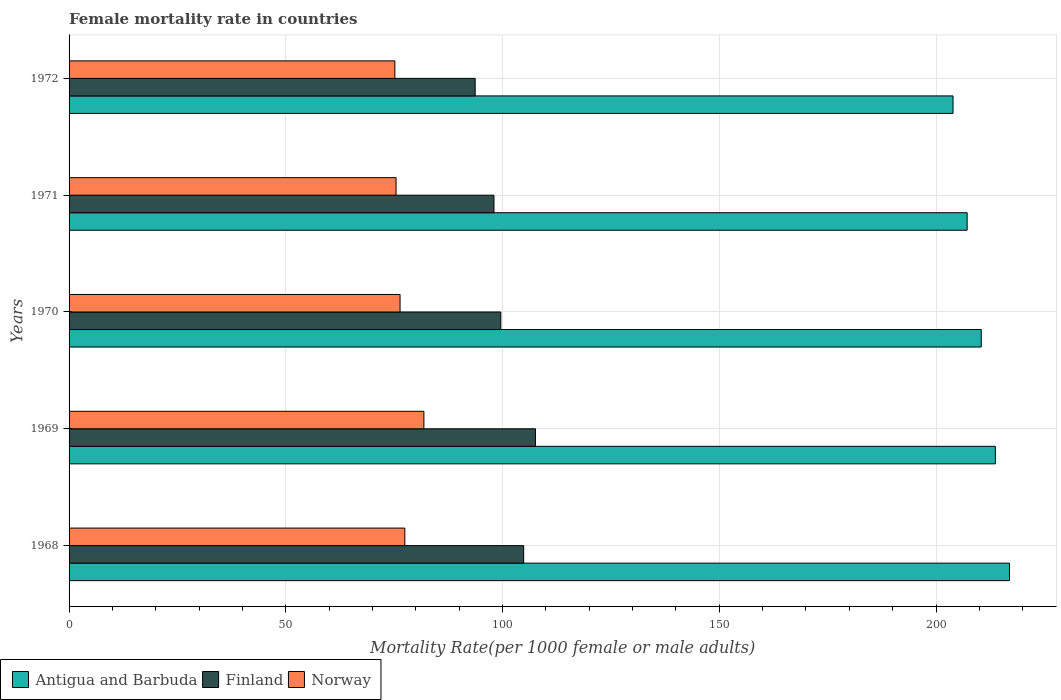How many different coloured bars are there?
Your answer should be compact. 3. How many groups of bars are there?
Provide a succinct answer. 5. Are the number of bars per tick equal to the number of legend labels?
Give a very brief answer. Yes. How many bars are there on the 3rd tick from the bottom?
Make the answer very short. 3. What is the label of the 4th group of bars from the top?
Your response must be concise. 1969. In how many cases, is the number of bars for a given year not equal to the number of legend labels?
Your answer should be very brief. 0. What is the female mortality rate in Norway in 1970?
Make the answer very short. 76.36. Across all years, what is the maximum female mortality rate in Antigua and Barbuda?
Ensure brevity in your answer.  216.95. Across all years, what is the minimum female mortality rate in Antigua and Barbuda?
Offer a very short reply. 203.93. In which year was the female mortality rate in Antigua and Barbuda maximum?
Give a very brief answer. 1968. What is the total female mortality rate in Antigua and Barbuda in the graph?
Your response must be concise. 1052.2. What is the difference between the female mortality rate in Norway in 1968 and that in 1972?
Make the answer very short. 2.3. What is the difference between the female mortality rate in Antigua and Barbuda in 1970 and the female mortality rate in Norway in 1972?
Your response must be concise. 135.28. What is the average female mortality rate in Finland per year?
Make the answer very short. 100.76. In the year 1968, what is the difference between the female mortality rate in Norway and female mortality rate in Finland?
Your response must be concise. -27.41. In how many years, is the female mortality rate in Antigua and Barbuda greater than 10 ?
Make the answer very short. 5. What is the ratio of the female mortality rate in Finland in 1969 to that in 1971?
Your answer should be very brief. 1.1. Is the difference between the female mortality rate in Norway in 1968 and 1970 greater than the difference between the female mortality rate in Finland in 1968 and 1970?
Keep it short and to the point. No. What is the difference between the highest and the second highest female mortality rate in Antigua and Barbuda?
Ensure brevity in your answer.  3.25. What is the difference between the highest and the lowest female mortality rate in Finland?
Give a very brief answer. 13.9. In how many years, is the female mortality rate in Antigua and Barbuda greater than the average female mortality rate in Antigua and Barbuda taken over all years?
Provide a short and direct response. 3. Are all the bars in the graph horizontal?
Offer a terse response. Yes. How many years are there in the graph?
Provide a succinct answer. 5. What is the difference between two consecutive major ticks on the X-axis?
Your answer should be compact. 50. Are the values on the major ticks of X-axis written in scientific E-notation?
Your response must be concise. No. Does the graph contain any zero values?
Offer a very short reply. No. How many legend labels are there?
Your answer should be compact. 3. What is the title of the graph?
Keep it short and to the point. Female mortality rate in countries. What is the label or title of the X-axis?
Make the answer very short. Mortality Rate(per 1000 female or male adults). What is the label or title of the Y-axis?
Keep it short and to the point. Years. What is the Mortality Rate(per 1000 female or male adults) in Antigua and Barbuda in 1968?
Provide a short and direct response. 216.95. What is the Mortality Rate(per 1000 female or male adults) of Finland in 1968?
Your answer should be very brief. 104.88. What is the Mortality Rate(per 1000 female or male adults) in Norway in 1968?
Make the answer very short. 77.46. What is the Mortality Rate(per 1000 female or male adults) in Antigua and Barbuda in 1969?
Your response must be concise. 213.7. What is the Mortality Rate(per 1000 female or male adults) in Finland in 1969?
Your response must be concise. 107.59. What is the Mortality Rate(per 1000 female or male adults) of Norway in 1969?
Provide a succinct answer. 81.86. What is the Mortality Rate(per 1000 female or male adults) of Antigua and Barbuda in 1970?
Give a very brief answer. 210.44. What is the Mortality Rate(per 1000 female or male adults) in Finland in 1970?
Provide a short and direct response. 99.6. What is the Mortality Rate(per 1000 female or male adults) of Norway in 1970?
Offer a very short reply. 76.36. What is the Mortality Rate(per 1000 female or male adults) in Antigua and Barbuda in 1971?
Offer a terse response. 207.19. What is the Mortality Rate(per 1000 female or male adults) in Finland in 1971?
Make the answer very short. 98.03. What is the Mortality Rate(per 1000 female or male adults) of Norway in 1971?
Give a very brief answer. 75.44. What is the Mortality Rate(per 1000 female or male adults) of Antigua and Barbuda in 1972?
Offer a very short reply. 203.93. What is the Mortality Rate(per 1000 female or male adults) in Finland in 1972?
Give a very brief answer. 93.69. What is the Mortality Rate(per 1000 female or male adults) in Norway in 1972?
Keep it short and to the point. 75.16. Across all years, what is the maximum Mortality Rate(per 1000 female or male adults) of Antigua and Barbuda?
Ensure brevity in your answer.  216.95. Across all years, what is the maximum Mortality Rate(per 1000 female or male adults) of Finland?
Ensure brevity in your answer.  107.59. Across all years, what is the maximum Mortality Rate(per 1000 female or male adults) of Norway?
Keep it short and to the point. 81.86. Across all years, what is the minimum Mortality Rate(per 1000 female or male adults) in Antigua and Barbuda?
Your answer should be compact. 203.93. Across all years, what is the minimum Mortality Rate(per 1000 female or male adults) in Finland?
Keep it short and to the point. 93.69. Across all years, what is the minimum Mortality Rate(per 1000 female or male adults) in Norway?
Provide a succinct answer. 75.16. What is the total Mortality Rate(per 1000 female or male adults) of Antigua and Barbuda in the graph?
Offer a terse response. 1052.2. What is the total Mortality Rate(per 1000 female or male adults) in Finland in the graph?
Make the answer very short. 503.79. What is the total Mortality Rate(per 1000 female or male adults) of Norway in the graph?
Keep it short and to the point. 386.28. What is the difference between the Mortality Rate(per 1000 female or male adults) in Antigua and Barbuda in 1968 and that in 1969?
Your answer should be compact. 3.25. What is the difference between the Mortality Rate(per 1000 female or male adults) in Finland in 1968 and that in 1969?
Keep it short and to the point. -2.71. What is the difference between the Mortality Rate(per 1000 female or male adults) in Norway in 1968 and that in 1969?
Give a very brief answer. -4.39. What is the difference between the Mortality Rate(per 1000 female or male adults) in Antigua and Barbuda in 1968 and that in 1970?
Provide a succinct answer. 6.51. What is the difference between the Mortality Rate(per 1000 female or male adults) of Finland in 1968 and that in 1970?
Provide a short and direct response. 5.27. What is the difference between the Mortality Rate(per 1000 female or male adults) in Norway in 1968 and that in 1970?
Give a very brief answer. 1.1. What is the difference between the Mortality Rate(per 1000 female or male adults) in Antigua and Barbuda in 1968 and that in 1971?
Your answer should be compact. 9.77. What is the difference between the Mortality Rate(per 1000 female or male adults) of Finland in 1968 and that in 1971?
Make the answer very short. 6.85. What is the difference between the Mortality Rate(per 1000 female or male adults) of Norway in 1968 and that in 1971?
Ensure brevity in your answer.  2.02. What is the difference between the Mortality Rate(per 1000 female or male adults) of Antigua and Barbuda in 1968 and that in 1972?
Your answer should be very brief. 13.02. What is the difference between the Mortality Rate(per 1000 female or male adults) in Finland in 1968 and that in 1972?
Provide a succinct answer. 11.19. What is the difference between the Mortality Rate(per 1000 female or male adults) of Norway in 1968 and that in 1972?
Ensure brevity in your answer.  2.3. What is the difference between the Mortality Rate(per 1000 female or male adults) of Antigua and Barbuda in 1969 and that in 1970?
Your response must be concise. 3.25. What is the difference between the Mortality Rate(per 1000 female or male adults) in Finland in 1969 and that in 1970?
Provide a short and direct response. 7.99. What is the difference between the Mortality Rate(per 1000 female or male adults) of Norway in 1969 and that in 1970?
Ensure brevity in your answer.  5.5. What is the difference between the Mortality Rate(per 1000 female or male adults) in Antigua and Barbuda in 1969 and that in 1971?
Your response must be concise. 6.51. What is the difference between the Mortality Rate(per 1000 female or male adults) in Finland in 1969 and that in 1971?
Offer a terse response. 9.57. What is the difference between the Mortality Rate(per 1000 female or male adults) in Norway in 1969 and that in 1971?
Keep it short and to the point. 6.42. What is the difference between the Mortality Rate(per 1000 female or male adults) of Antigua and Barbuda in 1969 and that in 1972?
Provide a succinct answer. 9.77. What is the difference between the Mortality Rate(per 1000 female or male adults) in Finland in 1969 and that in 1972?
Make the answer very short. 13.9. What is the difference between the Mortality Rate(per 1000 female or male adults) in Norway in 1969 and that in 1972?
Provide a succinct answer. 6.7. What is the difference between the Mortality Rate(per 1000 female or male adults) in Antigua and Barbuda in 1970 and that in 1971?
Your answer should be compact. 3.26. What is the difference between the Mortality Rate(per 1000 female or male adults) in Finland in 1970 and that in 1971?
Your answer should be compact. 1.58. What is the difference between the Mortality Rate(per 1000 female or male adults) of Norway in 1970 and that in 1971?
Keep it short and to the point. 0.92. What is the difference between the Mortality Rate(per 1000 female or male adults) of Antigua and Barbuda in 1970 and that in 1972?
Keep it short and to the point. 6.51. What is the difference between the Mortality Rate(per 1000 female or male adults) of Finland in 1970 and that in 1972?
Your answer should be compact. 5.92. What is the difference between the Mortality Rate(per 1000 female or male adults) in Norway in 1970 and that in 1972?
Make the answer very short. 1.2. What is the difference between the Mortality Rate(per 1000 female or male adults) in Antigua and Barbuda in 1971 and that in 1972?
Your answer should be very brief. 3.25. What is the difference between the Mortality Rate(per 1000 female or male adults) of Finland in 1971 and that in 1972?
Give a very brief answer. 4.34. What is the difference between the Mortality Rate(per 1000 female or male adults) in Norway in 1971 and that in 1972?
Offer a terse response. 0.28. What is the difference between the Mortality Rate(per 1000 female or male adults) in Antigua and Barbuda in 1968 and the Mortality Rate(per 1000 female or male adults) in Finland in 1969?
Offer a terse response. 109.36. What is the difference between the Mortality Rate(per 1000 female or male adults) in Antigua and Barbuda in 1968 and the Mortality Rate(per 1000 female or male adults) in Norway in 1969?
Your answer should be compact. 135.09. What is the difference between the Mortality Rate(per 1000 female or male adults) in Finland in 1968 and the Mortality Rate(per 1000 female or male adults) in Norway in 1969?
Your answer should be compact. 23.02. What is the difference between the Mortality Rate(per 1000 female or male adults) in Antigua and Barbuda in 1968 and the Mortality Rate(per 1000 female or male adults) in Finland in 1970?
Offer a terse response. 117.35. What is the difference between the Mortality Rate(per 1000 female or male adults) in Antigua and Barbuda in 1968 and the Mortality Rate(per 1000 female or male adults) in Norway in 1970?
Make the answer very short. 140.59. What is the difference between the Mortality Rate(per 1000 female or male adults) of Finland in 1968 and the Mortality Rate(per 1000 female or male adults) of Norway in 1970?
Give a very brief answer. 28.52. What is the difference between the Mortality Rate(per 1000 female or male adults) of Antigua and Barbuda in 1968 and the Mortality Rate(per 1000 female or male adults) of Finland in 1971?
Your response must be concise. 118.93. What is the difference between the Mortality Rate(per 1000 female or male adults) in Antigua and Barbuda in 1968 and the Mortality Rate(per 1000 female or male adults) in Norway in 1971?
Make the answer very short. 141.51. What is the difference between the Mortality Rate(per 1000 female or male adults) of Finland in 1968 and the Mortality Rate(per 1000 female or male adults) of Norway in 1971?
Your answer should be very brief. 29.44. What is the difference between the Mortality Rate(per 1000 female or male adults) in Antigua and Barbuda in 1968 and the Mortality Rate(per 1000 female or male adults) in Finland in 1972?
Your answer should be very brief. 123.26. What is the difference between the Mortality Rate(per 1000 female or male adults) of Antigua and Barbuda in 1968 and the Mortality Rate(per 1000 female or male adults) of Norway in 1972?
Offer a very short reply. 141.79. What is the difference between the Mortality Rate(per 1000 female or male adults) in Finland in 1968 and the Mortality Rate(per 1000 female or male adults) in Norway in 1972?
Provide a short and direct response. 29.72. What is the difference between the Mortality Rate(per 1000 female or male adults) in Antigua and Barbuda in 1969 and the Mortality Rate(per 1000 female or male adults) in Finland in 1970?
Keep it short and to the point. 114.09. What is the difference between the Mortality Rate(per 1000 female or male adults) in Antigua and Barbuda in 1969 and the Mortality Rate(per 1000 female or male adults) in Norway in 1970?
Make the answer very short. 137.34. What is the difference between the Mortality Rate(per 1000 female or male adults) in Finland in 1969 and the Mortality Rate(per 1000 female or male adults) in Norway in 1970?
Ensure brevity in your answer.  31.23. What is the difference between the Mortality Rate(per 1000 female or male adults) of Antigua and Barbuda in 1969 and the Mortality Rate(per 1000 female or male adults) of Finland in 1971?
Give a very brief answer. 115.67. What is the difference between the Mortality Rate(per 1000 female or male adults) of Antigua and Barbuda in 1969 and the Mortality Rate(per 1000 female or male adults) of Norway in 1971?
Offer a very short reply. 138.25. What is the difference between the Mortality Rate(per 1000 female or male adults) in Finland in 1969 and the Mortality Rate(per 1000 female or male adults) in Norway in 1971?
Offer a terse response. 32.15. What is the difference between the Mortality Rate(per 1000 female or male adults) in Antigua and Barbuda in 1969 and the Mortality Rate(per 1000 female or male adults) in Finland in 1972?
Offer a very short reply. 120.01. What is the difference between the Mortality Rate(per 1000 female or male adults) in Antigua and Barbuda in 1969 and the Mortality Rate(per 1000 female or male adults) in Norway in 1972?
Your answer should be very brief. 138.53. What is the difference between the Mortality Rate(per 1000 female or male adults) in Finland in 1969 and the Mortality Rate(per 1000 female or male adults) in Norway in 1972?
Provide a succinct answer. 32.43. What is the difference between the Mortality Rate(per 1000 female or male adults) of Antigua and Barbuda in 1970 and the Mortality Rate(per 1000 female or male adults) of Finland in 1971?
Keep it short and to the point. 112.42. What is the difference between the Mortality Rate(per 1000 female or male adults) of Antigua and Barbuda in 1970 and the Mortality Rate(per 1000 female or male adults) of Norway in 1971?
Your answer should be compact. 135. What is the difference between the Mortality Rate(per 1000 female or male adults) in Finland in 1970 and the Mortality Rate(per 1000 female or male adults) in Norway in 1971?
Provide a succinct answer. 24.16. What is the difference between the Mortality Rate(per 1000 female or male adults) in Antigua and Barbuda in 1970 and the Mortality Rate(per 1000 female or male adults) in Finland in 1972?
Keep it short and to the point. 116.75. What is the difference between the Mortality Rate(per 1000 female or male adults) in Antigua and Barbuda in 1970 and the Mortality Rate(per 1000 female or male adults) in Norway in 1972?
Give a very brief answer. 135.28. What is the difference between the Mortality Rate(per 1000 female or male adults) of Finland in 1970 and the Mortality Rate(per 1000 female or male adults) of Norway in 1972?
Offer a terse response. 24.44. What is the difference between the Mortality Rate(per 1000 female or male adults) of Antigua and Barbuda in 1971 and the Mortality Rate(per 1000 female or male adults) of Finland in 1972?
Give a very brief answer. 113.5. What is the difference between the Mortality Rate(per 1000 female or male adults) of Antigua and Barbuda in 1971 and the Mortality Rate(per 1000 female or male adults) of Norway in 1972?
Your answer should be very brief. 132.02. What is the difference between the Mortality Rate(per 1000 female or male adults) in Finland in 1971 and the Mortality Rate(per 1000 female or male adults) in Norway in 1972?
Provide a succinct answer. 22.86. What is the average Mortality Rate(per 1000 female or male adults) of Antigua and Barbuda per year?
Keep it short and to the point. 210.44. What is the average Mortality Rate(per 1000 female or male adults) of Finland per year?
Make the answer very short. 100.76. What is the average Mortality Rate(per 1000 female or male adults) in Norway per year?
Your answer should be very brief. 77.26. In the year 1968, what is the difference between the Mortality Rate(per 1000 female or male adults) of Antigua and Barbuda and Mortality Rate(per 1000 female or male adults) of Finland?
Provide a short and direct response. 112.07. In the year 1968, what is the difference between the Mortality Rate(per 1000 female or male adults) in Antigua and Barbuda and Mortality Rate(per 1000 female or male adults) in Norway?
Your answer should be very brief. 139.49. In the year 1968, what is the difference between the Mortality Rate(per 1000 female or male adults) of Finland and Mortality Rate(per 1000 female or male adults) of Norway?
Provide a short and direct response. 27.41. In the year 1969, what is the difference between the Mortality Rate(per 1000 female or male adults) of Antigua and Barbuda and Mortality Rate(per 1000 female or male adults) of Finland?
Make the answer very short. 106.1. In the year 1969, what is the difference between the Mortality Rate(per 1000 female or male adults) of Antigua and Barbuda and Mortality Rate(per 1000 female or male adults) of Norway?
Your response must be concise. 131.84. In the year 1969, what is the difference between the Mortality Rate(per 1000 female or male adults) in Finland and Mortality Rate(per 1000 female or male adults) in Norway?
Your answer should be compact. 25.74. In the year 1970, what is the difference between the Mortality Rate(per 1000 female or male adults) in Antigua and Barbuda and Mortality Rate(per 1000 female or male adults) in Finland?
Your answer should be very brief. 110.84. In the year 1970, what is the difference between the Mortality Rate(per 1000 female or male adults) of Antigua and Barbuda and Mortality Rate(per 1000 female or male adults) of Norway?
Provide a short and direct response. 134.08. In the year 1970, what is the difference between the Mortality Rate(per 1000 female or male adults) in Finland and Mortality Rate(per 1000 female or male adults) in Norway?
Offer a terse response. 23.24. In the year 1971, what is the difference between the Mortality Rate(per 1000 female or male adults) in Antigua and Barbuda and Mortality Rate(per 1000 female or male adults) in Finland?
Offer a very short reply. 109.16. In the year 1971, what is the difference between the Mortality Rate(per 1000 female or male adults) in Antigua and Barbuda and Mortality Rate(per 1000 female or male adults) in Norway?
Make the answer very short. 131.74. In the year 1971, what is the difference between the Mortality Rate(per 1000 female or male adults) of Finland and Mortality Rate(per 1000 female or male adults) of Norway?
Give a very brief answer. 22.58. In the year 1972, what is the difference between the Mortality Rate(per 1000 female or male adults) of Antigua and Barbuda and Mortality Rate(per 1000 female or male adults) of Finland?
Keep it short and to the point. 110.24. In the year 1972, what is the difference between the Mortality Rate(per 1000 female or male adults) in Antigua and Barbuda and Mortality Rate(per 1000 female or male adults) in Norway?
Your answer should be compact. 128.77. In the year 1972, what is the difference between the Mortality Rate(per 1000 female or male adults) in Finland and Mortality Rate(per 1000 female or male adults) in Norway?
Offer a very short reply. 18.53. What is the ratio of the Mortality Rate(per 1000 female or male adults) of Antigua and Barbuda in 1968 to that in 1969?
Ensure brevity in your answer.  1.02. What is the ratio of the Mortality Rate(per 1000 female or male adults) in Finland in 1968 to that in 1969?
Provide a succinct answer. 0.97. What is the ratio of the Mortality Rate(per 1000 female or male adults) of Norway in 1968 to that in 1969?
Ensure brevity in your answer.  0.95. What is the ratio of the Mortality Rate(per 1000 female or male adults) in Antigua and Barbuda in 1968 to that in 1970?
Offer a terse response. 1.03. What is the ratio of the Mortality Rate(per 1000 female or male adults) in Finland in 1968 to that in 1970?
Give a very brief answer. 1.05. What is the ratio of the Mortality Rate(per 1000 female or male adults) of Norway in 1968 to that in 1970?
Offer a very short reply. 1.01. What is the ratio of the Mortality Rate(per 1000 female or male adults) of Antigua and Barbuda in 1968 to that in 1971?
Keep it short and to the point. 1.05. What is the ratio of the Mortality Rate(per 1000 female or male adults) in Finland in 1968 to that in 1971?
Keep it short and to the point. 1.07. What is the ratio of the Mortality Rate(per 1000 female or male adults) in Norway in 1968 to that in 1971?
Keep it short and to the point. 1.03. What is the ratio of the Mortality Rate(per 1000 female or male adults) in Antigua and Barbuda in 1968 to that in 1972?
Keep it short and to the point. 1.06. What is the ratio of the Mortality Rate(per 1000 female or male adults) of Finland in 1968 to that in 1972?
Keep it short and to the point. 1.12. What is the ratio of the Mortality Rate(per 1000 female or male adults) of Norway in 1968 to that in 1972?
Keep it short and to the point. 1.03. What is the ratio of the Mortality Rate(per 1000 female or male adults) of Antigua and Barbuda in 1969 to that in 1970?
Your answer should be very brief. 1.02. What is the ratio of the Mortality Rate(per 1000 female or male adults) of Finland in 1969 to that in 1970?
Offer a terse response. 1.08. What is the ratio of the Mortality Rate(per 1000 female or male adults) of Norway in 1969 to that in 1970?
Ensure brevity in your answer.  1.07. What is the ratio of the Mortality Rate(per 1000 female or male adults) of Antigua and Barbuda in 1969 to that in 1971?
Make the answer very short. 1.03. What is the ratio of the Mortality Rate(per 1000 female or male adults) of Finland in 1969 to that in 1971?
Give a very brief answer. 1.1. What is the ratio of the Mortality Rate(per 1000 female or male adults) in Norway in 1969 to that in 1971?
Offer a very short reply. 1.08. What is the ratio of the Mortality Rate(per 1000 female or male adults) of Antigua and Barbuda in 1969 to that in 1972?
Provide a short and direct response. 1.05. What is the ratio of the Mortality Rate(per 1000 female or male adults) of Finland in 1969 to that in 1972?
Ensure brevity in your answer.  1.15. What is the ratio of the Mortality Rate(per 1000 female or male adults) of Norway in 1969 to that in 1972?
Your response must be concise. 1.09. What is the ratio of the Mortality Rate(per 1000 female or male adults) in Antigua and Barbuda in 1970 to that in 1971?
Your answer should be very brief. 1.02. What is the ratio of the Mortality Rate(per 1000 female or male adults) of Finland in 1970 to that in 1971?
Keep it short and to the point. 1.02. What is the ratio of the Mortality Rate(per 1000 female or male adults) in Norway in 1970 to that in 1971?
Your response must be concise. 1.01. What is the ratio of the Mortality Rate(per 1000 female or male adults) in Antigua and Barbuda in 1970 to that in 1972?
Give a very brief answer. 1.03. What is the ratio of the Mortality Rate(per 1000 female or male adults) in Finland in 1970 to that in 1972?
Provide a short and direct response. 1.06. What is the ratio of the Mortality Rate(per 1000 female or male adults) in Norway in 1970 to that in 1972?
Your answer should be very brief. 1.02. What is the ratio of the Mortality Rate(per 1000 female or male adults) in Finland in 1971 to that in 1972?
Give a very brief answer. 1.05. What is the ratio of the Mortality Rate(per 1000 female or male adults) in Norway in 1971 to that in 1972?
Your answer should be compact. 1. What is the difference between the highest and the second highest Mortality Rate(per 1000 female or male adults) of Antigua and Barbuda?
Your response must be concise. 3.25. What is the difference between the highest and the second highest Mortality Rate(per 1000 female or male adults) in Finland?
Make the answer very short. 2.71. What is the difference between the highest and the second highest Mortality Rate(per 1000 female or male adults) in Norway?
Your answer should be very brief. 4.39. What is the difference between the highest and the lowest Mortality Rate(per 1000 female or male adults) of Antigua and Barbuda?
Provide a succinct answer. 13.02. What is the difference between the highest and the lowest Mortality Rate(per 1000 female or male adults) of Finland?
Your response must be concise. 13.9. What is the difference between the highest and the lowest Mortality Rate(per 1000 female or male adults) in Norway?
Offer a very short reply. 6.7. 